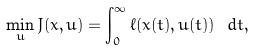<formula> <loc_0><loc_0><loc_500><loc_500>\min _ { u } J ( { x } , { u } ) = \int _ { 0 } ^ { \infty } \ell ( { x } ( t ) , { u } ( t ) ) \ d t ,</formula> 